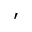Convert formula to latex. <formula><loc_0><loc_0><loc_500><loc_500>^ { \prime }</formula> 